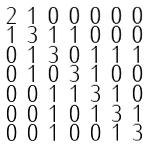Convert formula to latex. <formula><loc_0><loc_0><loc_500><loc_500>\begin{smallmatrix} 2 & 1 & 0 & 0 & 0 & 0 & 0 \\ 1 & 3 & 1 & 1 & 0 & 0 & 0 \\ 0 & 1 & 3 & 0 & 1 & 1 & 1 \\ 0 & 1 & 0 & 3 & 1 & 0 & 0 \\ 0 & 0 & 1 & 1 & 3 & 1 & 0 \\ 0 & 0 & 1 & 0 & 1 & 3 & 1 \\ 0 & 0 & 1 & 0 & 0 & 1 & 3 \end{smallmatrix}</formula> 